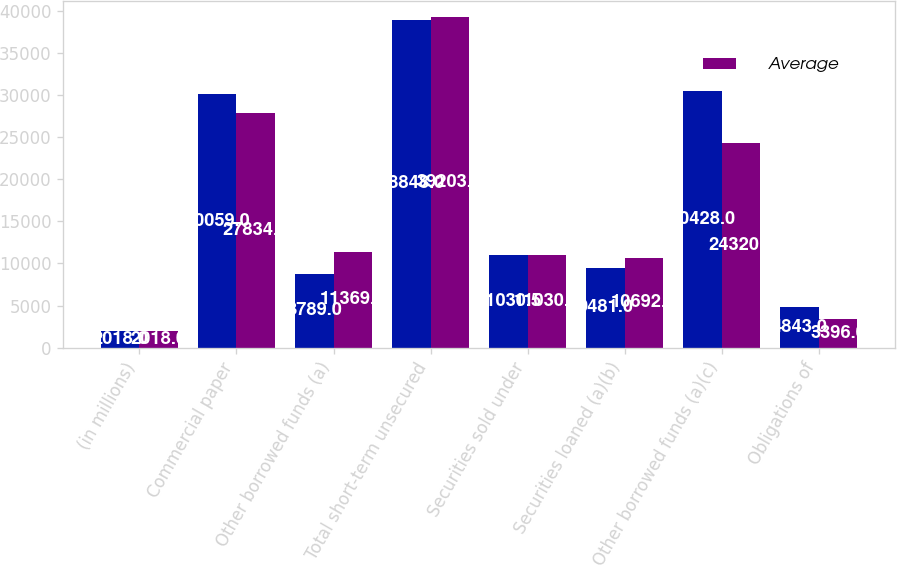Convert chart. <chart><loc_0><loc_0><loc_500><loc_500><stacked_bar_chart><ecel><fcel>(in millions)<fcel>Commercial paper<fcel>Other borrowed funds (a)<fcel>Total short-term unsecured<fcel>Securities sold under<fcel>Securities loaned (a)(b)<fcel>Other borrowed funds (a)(c)<fcel>Obligations of<nl><fcel>nan<fcel>2018<fcel>30059<fcel>8789<fcel>38848<fcel>11030.5<fcel>9481<fcel>30428<fcel>4843<nl><fcel>Average<fcel>2018<fcel>27834<fcel>11369<fcel>39203<fcel>11030.5<fcel>10692<fcel>24320<fcel>3396<nl></chart> 